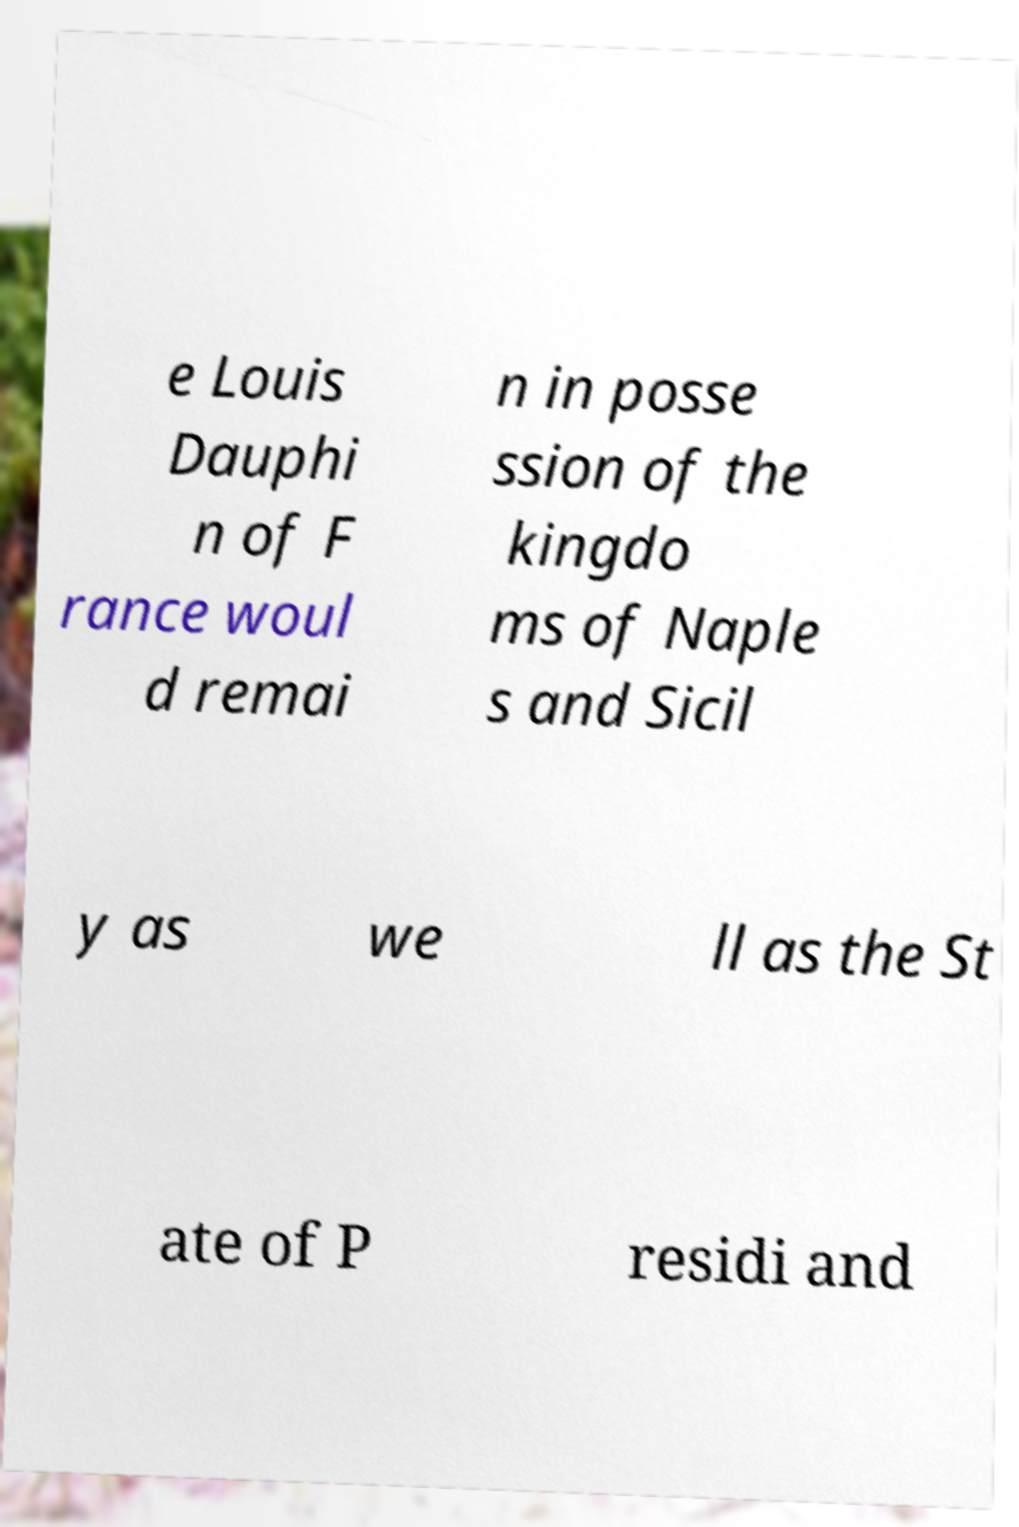Could you extract and type out the text from this image? e Louis Dauphi n of F rance woul d remai n in posse ssion of the kingdo ms of Naple s and Sicil y as we ll as the St ate of P residi and 